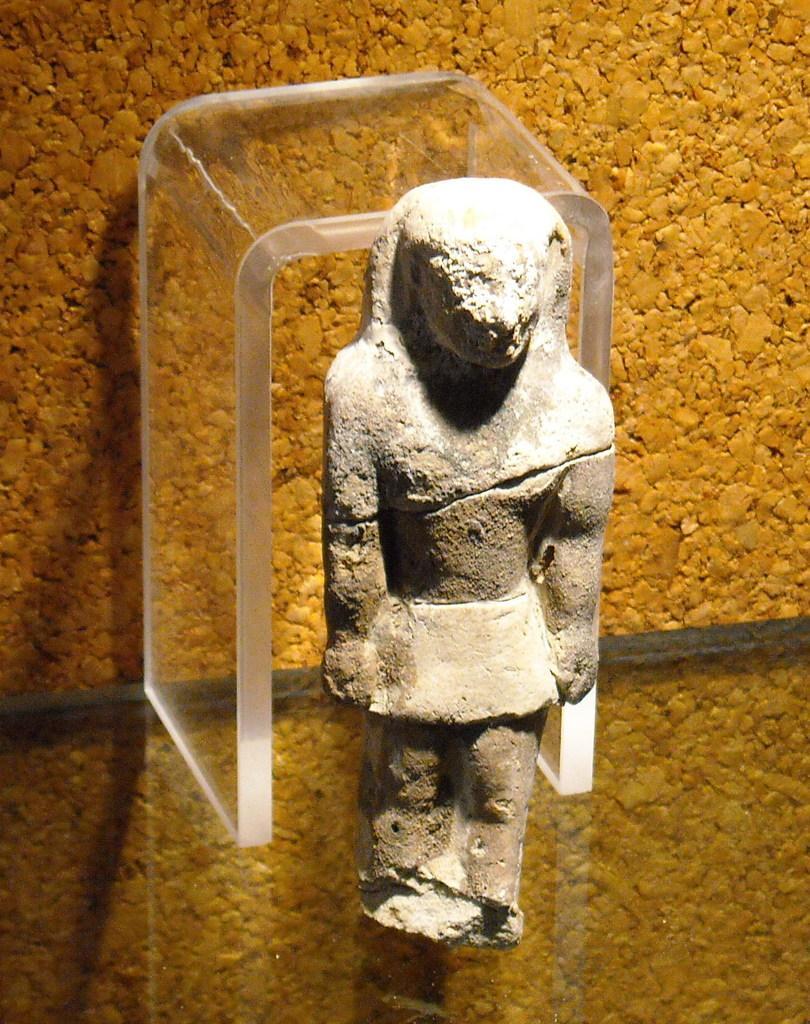Could you give a brief overview of what you see in this image? Here I can see a sculpture is placed on the glass. At the back of it there is another piece of glass. In the background there is a wall. 